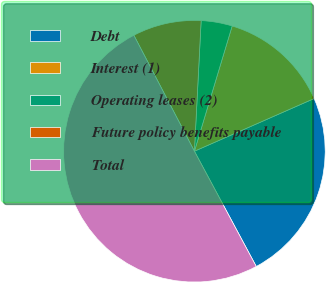<chart> <loc_0><loc_0><loc_500><loc_500><pie_chart><fcel>Debt<fcel>Interest (1)<fcel>Operating leases (2)<fcel>Future policy benefits payable<fcel>Total<nl><fcel>23.76%<fcel>13.74%<fcel>3.84%<fcel>8.48%<fcel>50.18%<nl></chart> 